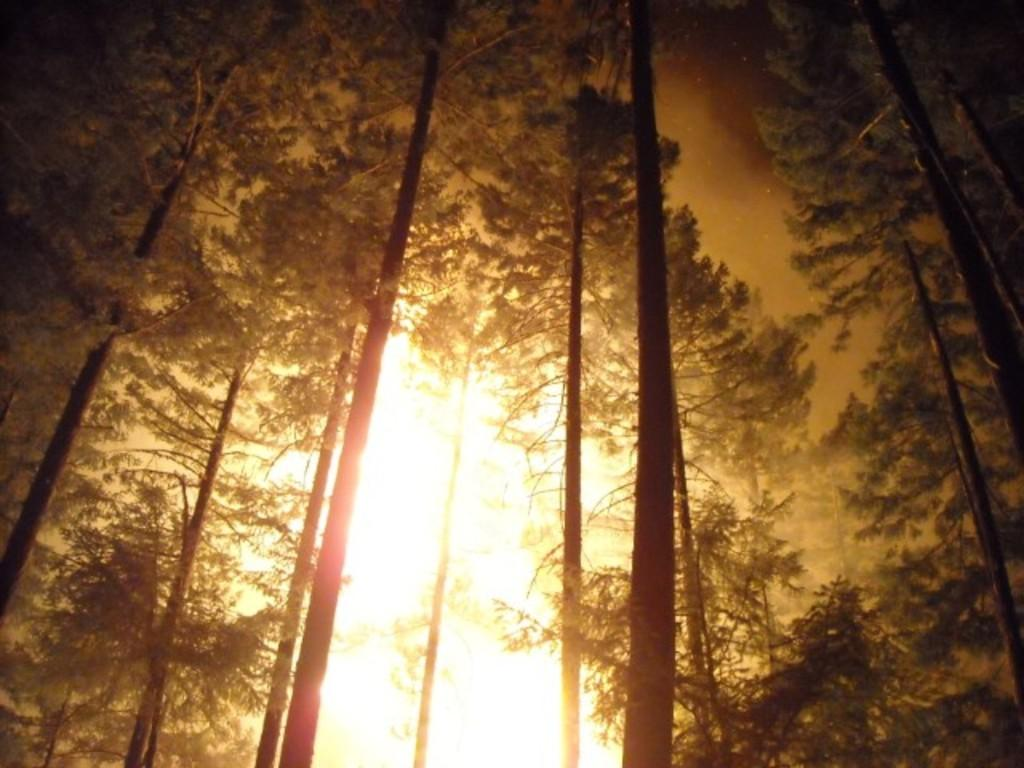What type of natural elements can be seen in the image? There are trees in the image. How are the trees arranged in the image? The trees are arranged from left to right. What type of legal advice can be obtained from the trees in the image? There are no lawyers or legal advice present in the image; it features trees arranged from left to right. 